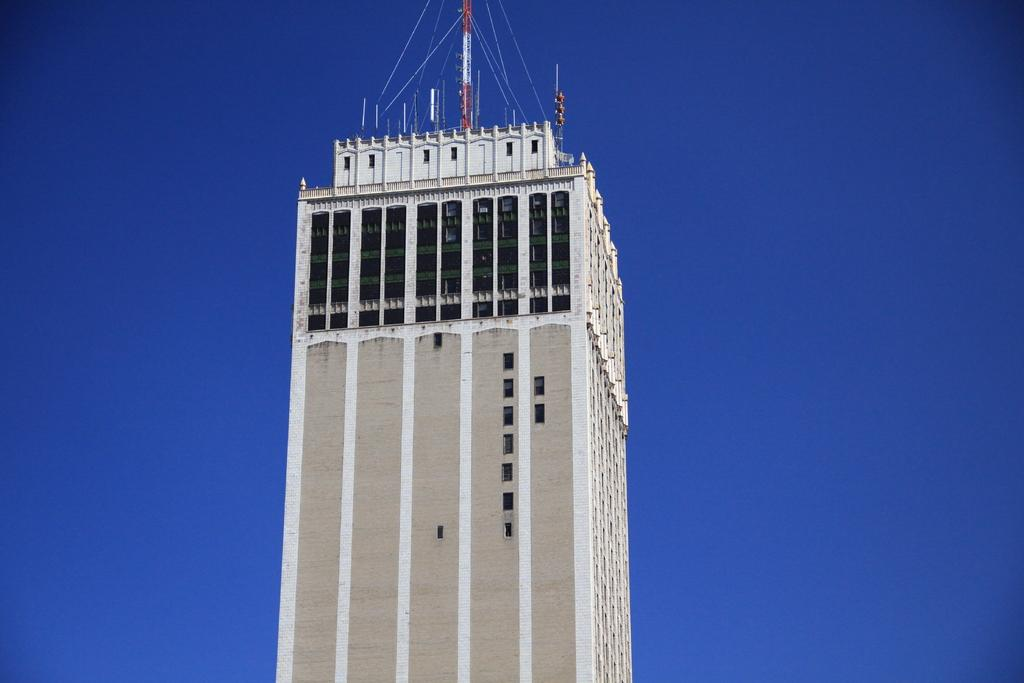What is the main structure in the image? There is a tower in the image. What is located on top of the tower? Antennas and signal poles are present on top of the tower. What can be seen in the background of the image? The sky is visible in the background of the image. How does the quince contribute to the functionality of the tower in the image? There is no quince present in the image, so it cannot contribute to the functionality of the tower. 